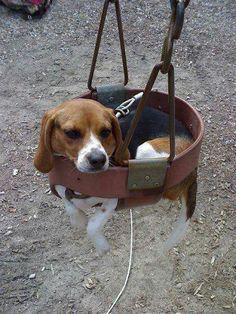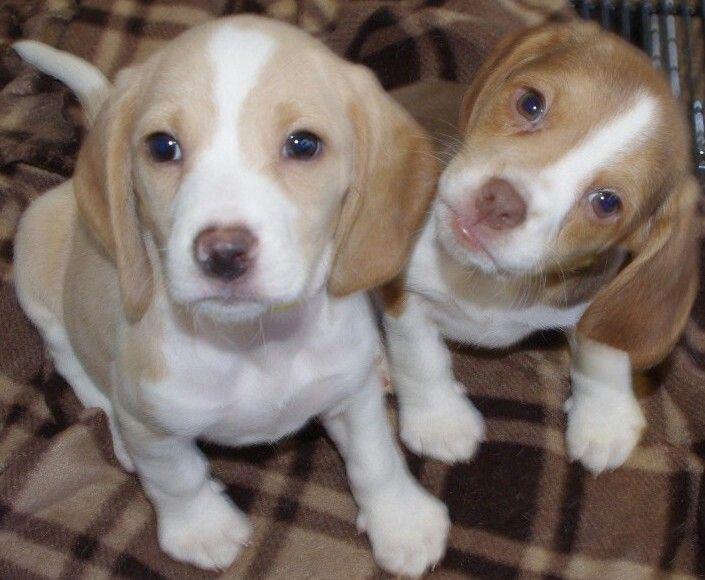The first image is the image on the left, the second image is the image on the right. Assess this claim about the two images: "There are no more than two dogs in the right image.". Correct or not? Answer yes or no. Yes. The first image is the image on the left, the second image is the image on the right. Examine the images to the left and right. Is the description "One image shows a beagle outdoors on grass, with its mouth next to a plastic object that is at least partly bright red." accurate? Answer yes or no. No. 